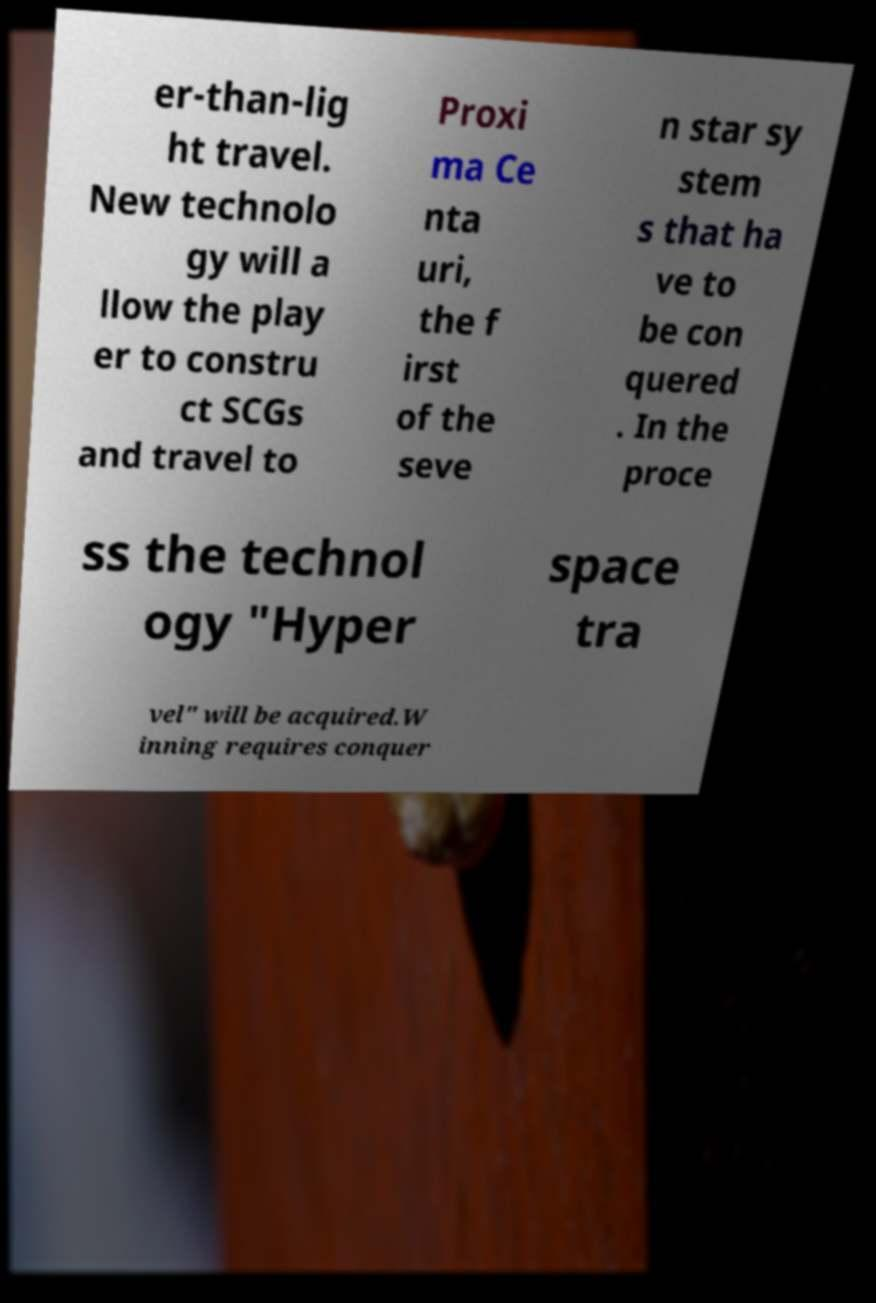Could you assist in decoding the text presented in this image and type it out clearly? er-than-lig ht travel. New technolo gy will a llow the play er to constru ct SCGs and travel to Proxi ma Ce nta uri, the f irst of the seve n star sy stem s that ha ve to be con quered . In the proce ss the technol ogy "Hyper space tra vel" will be acquired.W inning requires conquer 